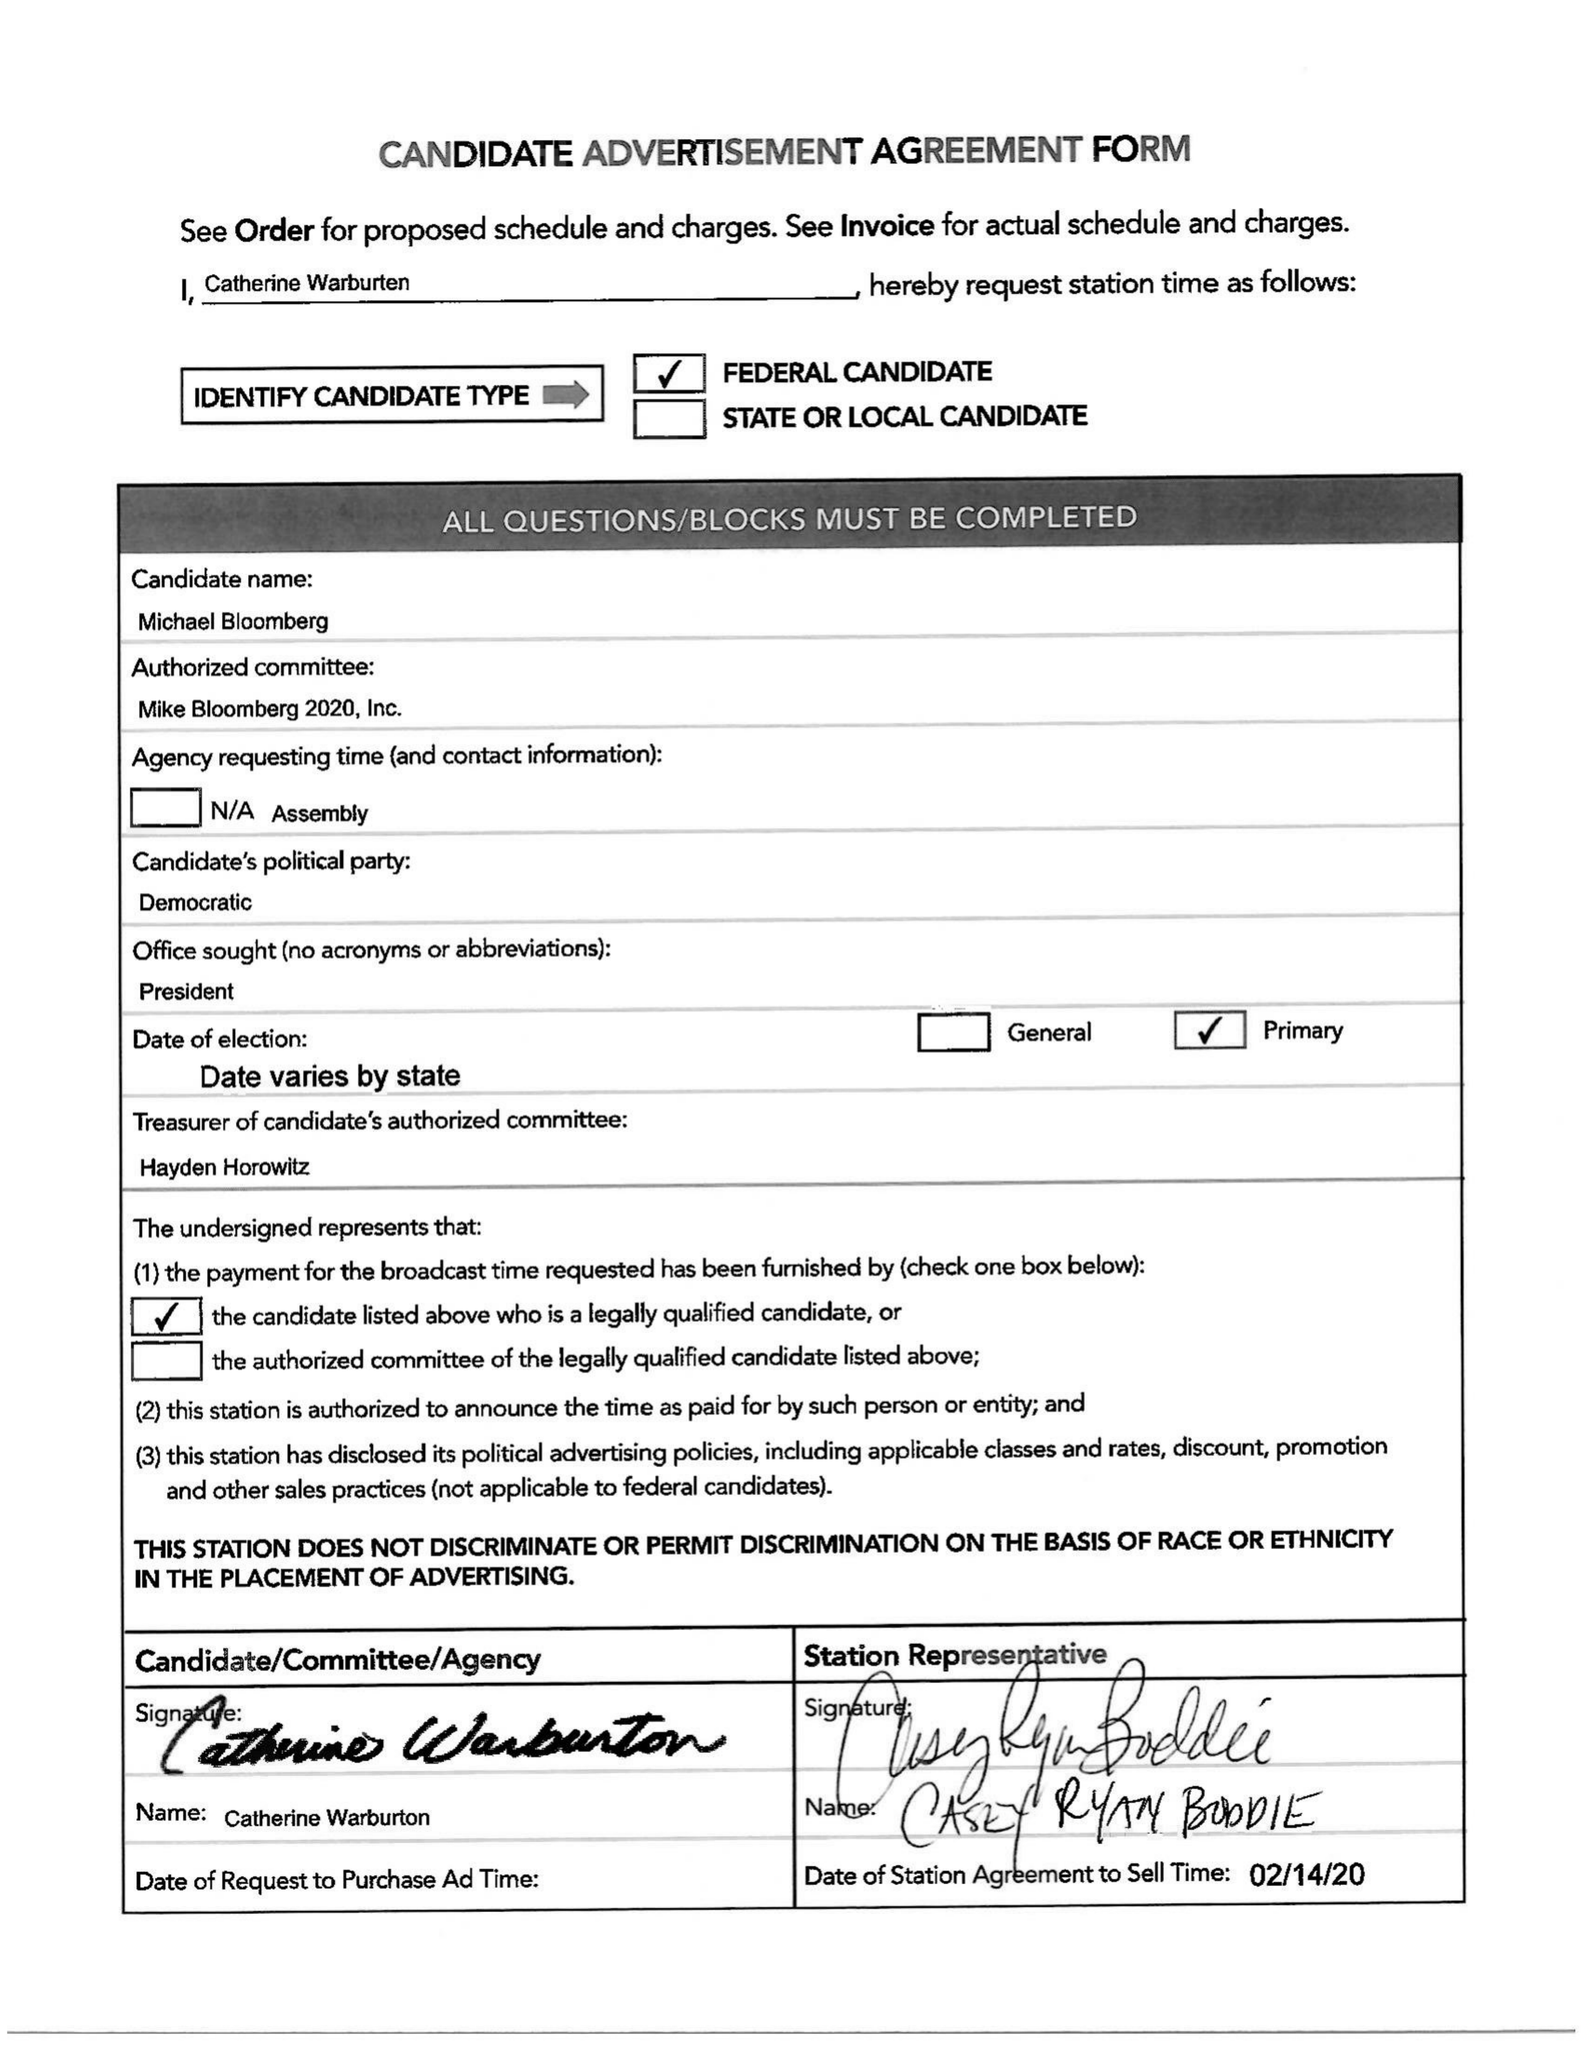What is the value for the flight_to?
Answer the question using a single word or phrase. 02/21/20 